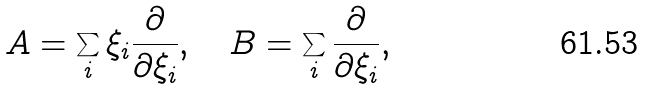Convert formula to latex. <formula><loc_0><loc_0><loc_500><loc_500>A = \sum _ { i } \xi _ { i } \frac { \partial } { \partial \xi _ { i } } , \quad B = \sum _ { i } \frac { \partial } { \partial \xi _ { i } } ,</formula> 